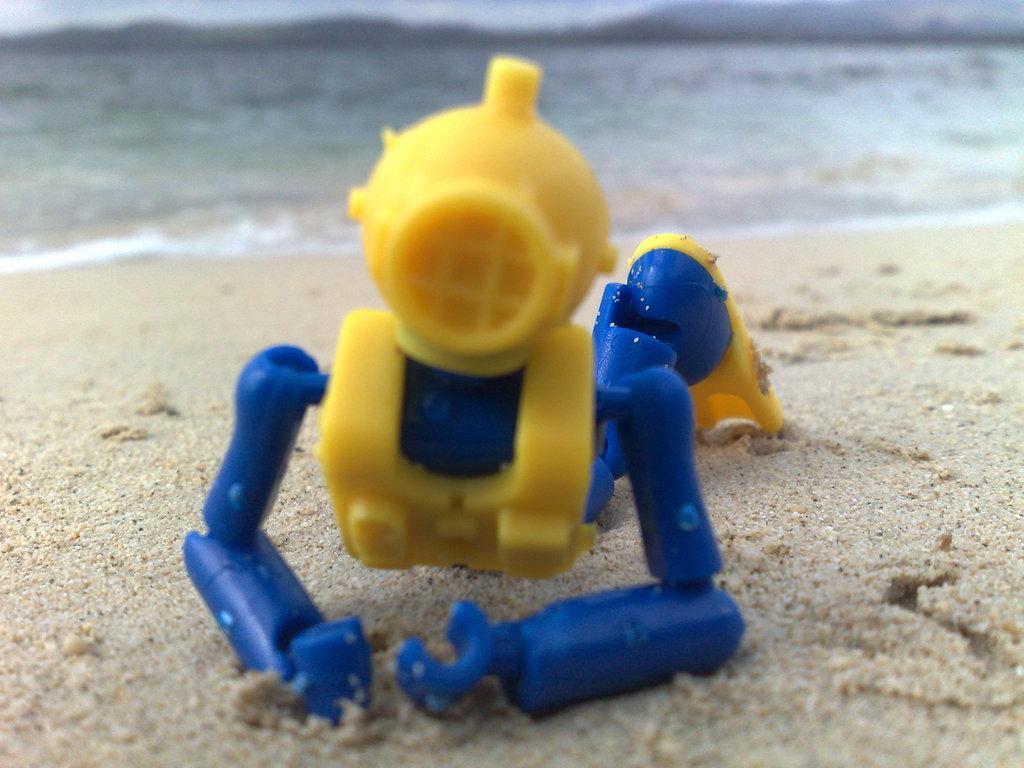How would you summarize this image in a sentence or two? In the center of the image there is a toy placed on a sand. In the background there is a water. 